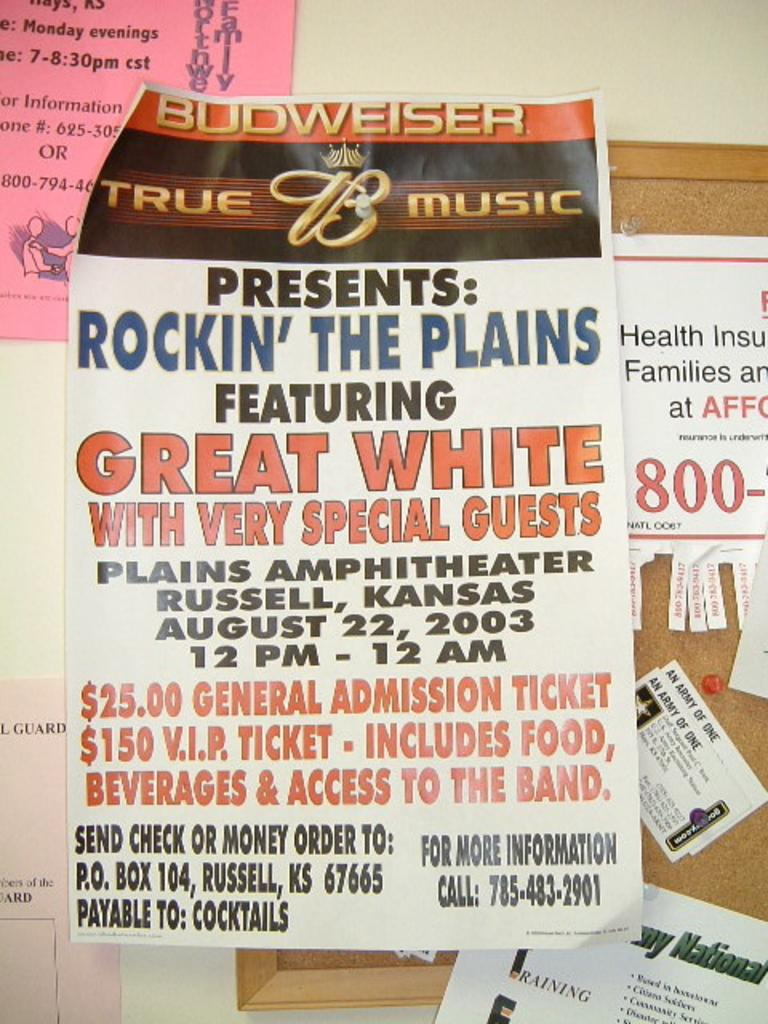<image>
Offer a succinct explanation of the picture presented. Poster on a wall for Rockin the Plains on August 22nd. 